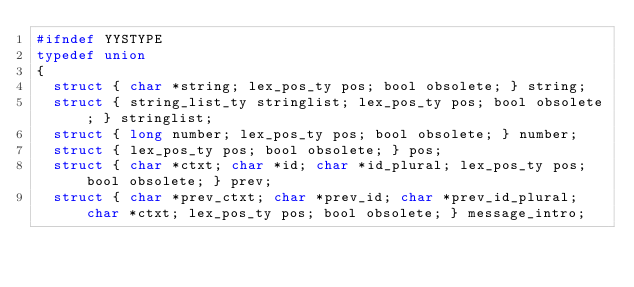Convert code to text. <code><loc_0><loc_0><loc_500><loc_500><_C_>#ifndef YYSTYPE
typedef union
{
  struct { char *string; lex_pos_ty pos; bool obsolete; } string;
  struct { string_list_ty stringlist; lex_pos_ty pos; bool obsolete; } stringlist;
  struct { long number; lex_pos_ty pos; bool obsolete; } number;
  struct { lex_pos_ty pos; bool obsolete; } pos;
  struct { char *ctxt; char *id; char *id_plural; lex_pos_ty pos; bool obsolete; } prev;
  struct { char *prev_ctxt; char *prev_id; char *prev_id_plural; char *ctxt; lex_pos_ty pos; bool obsolete; } message_intro;</code> 